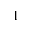Convert formula to latex. <formula><loc_0><loc_0><loc_500><loc_500>^ { 1 }</formula> 